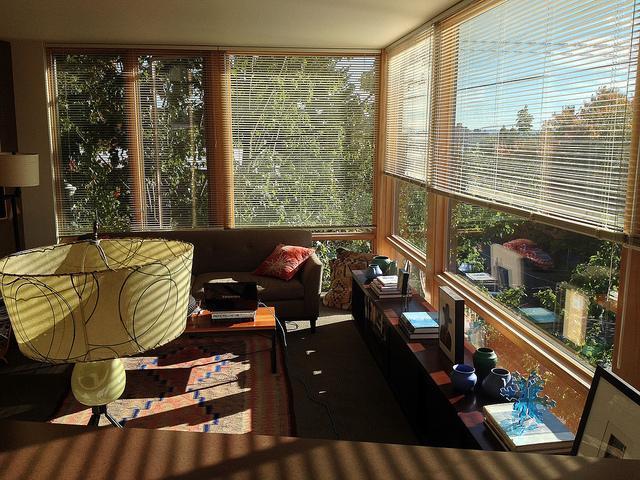How many couches are there?
Give a very brief answer. 1. How many windows on this airplane are touched by red or orange paint?
Give a very brief answer. 0. 